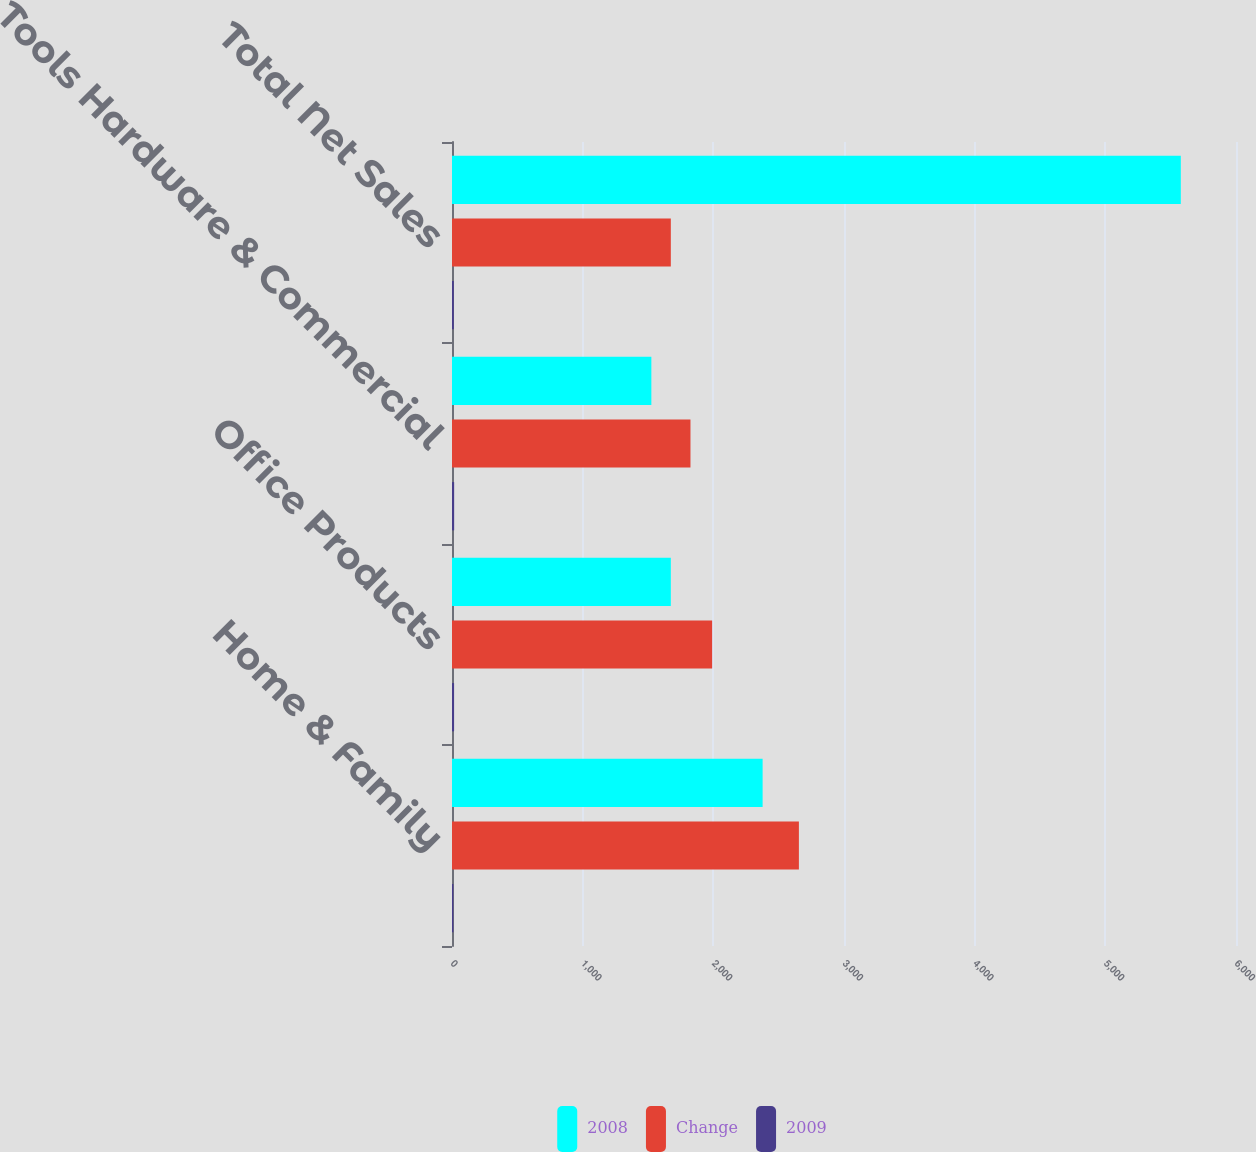Convert chart to OTSL. <chart><loc_0><loc_0><loc_500><loc_500><stacked_bar_chart><ecel><fcel>Home & Family<fcel>Office Products<fcel>Tools Hardware & Commercial<fcel>Total Net Sales<nl><fcel>2008<fcel>2377.2<fcel>1674.7<fcel>1525.7<fcel>5577.6<nl><fcel>Change<fcel>2654.8<fcel>1990.8<fcel>1825<fcel>1674.7<nl><fcel>2009<fcel>10.5<fcel>15.9<fcel>16.4<fcel>13.8<nl></chart> 